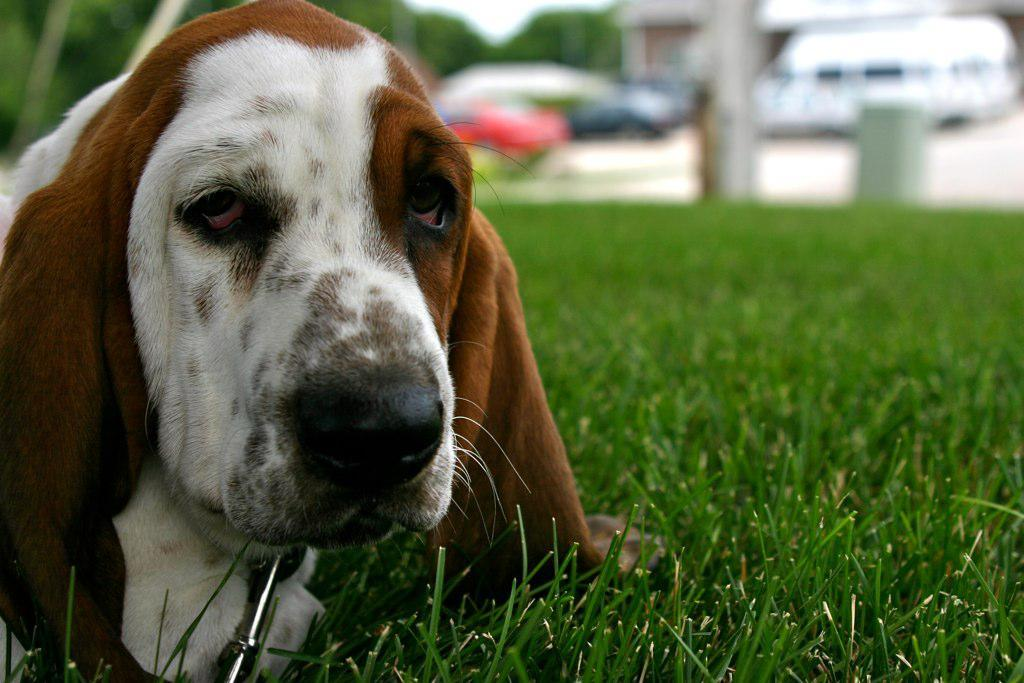What animal is present in the image? There is a dog in the image. Where is the dog located? The dog is on the grass. Can you describe the background of the image? The background of the image is blurred. How many planes can be seen attempting to fly at a high rate in the image? There are no planes present in the image, and therefore no such activity can be observed. 